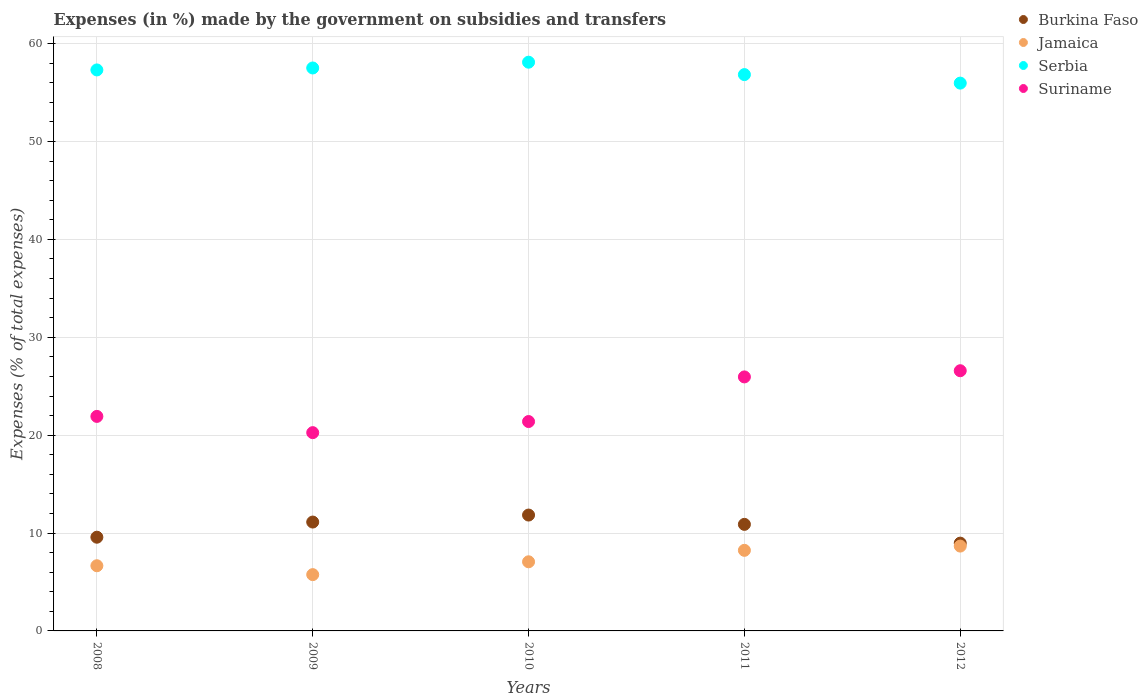How many different coloured dotlines are there?
Ensure brevity in your answer.  4. What is the percentage of expenses made by the government on subsidies and transfers in Suriname in 2009?
Your answer should be compact. 20.26. Across all years, what is the maximum percentage of expenses made by the government on subsidies and transfers in Burkina Faso?
Make the answer very short. 11.84. Across all years, what is the minimum percentage of expenses made by the government on subsidies and transfers in Burkina Faso?
Offer a very short reply. 8.97. What is the total percentage of expenses made by the government on subsidies and transfers in Jamaica in the graph?
Your answer should be compact. 36.37. What is the difference between the percentage of expenses made by the government on subsidies and transfers in Suriname in 2008 and that in 2009?
Your answer should be compact. 1.66. What is the difference between the percentage of expenses made by the government on subsidies and transfers in Burkina Faso in 2011 and the percentage of expenses made by the government on subsidies and transfers in Jamaica in 2012?
Offer a very short reply. 2.22. What is the average percentage of expenses made by the government on subsidies and transfers in Jamaica per year?
Offer a very short reply. 7.27. In the year 2009, what is the difference between the percentage of expenses made by the government on subsidies and transfers in Serbia and percentage of expenses made by the government on subsidies and transfers in Jamaica?
Your answer should be very brief. 51.76. What is the ratio of the percentage of expenses made by the government on subsidies and transfers in Serbia in 2008 to that in 2012?
Your answer should be very brief. 1.02. Is the percentage of expenses made by the government on subsidies and transfers in Suriname in 2008 less than that in 2011?
Make the answer very short. Yes. What is the difference between the highest and the second highest percentage of expenses made by the government on subsidies and transfers in Jamaica?
Your answer should be very brief. 0.43. What is the difference between the highest and the lowest percentage of expenses made by the government on subsidies and transfers in Burkina Faso?
Give a very brief answer. 2.87. Is the sum of the percentage of expenses made by the government on subsidies and transfers in Suriname in 2008 and 2012 greater than the maximum percentage of expenses made by the government on subsidies and transfers in Serbia across all years?
Your answer should be compact. No. Is it the case that in every year, the sum of the percentage of expenses made by the government on subsidies and transfers in Suriname and percentage of expenses made by the government on subsidies and transfers in Jamaica  is greater than the sum of percentage of expenses made by the government on subsidies and transfers in Serbia and percentage of expenses made by the government on subsidies and transfers in Burkina Faso?
Your answer should be compact. Yes. Is the percentage of expenses made by the government on subsidies and transfers in Serbia strictly greater than the percentage of expenses made by the government on subsidies and transfers in Burkina Faso over the years?
Ensure brevity in your answer.  Yes. Is the percentage of expenses made by the government on subsidies and transfers in Jamaica strictly less than the percentage of expenses made by the government on subsidies and transfers in Serbia over the years?
Keep it short and to the point. Yes. How many years are there in the graph?
Provide a succinct answer. 5. Where does the legend appear in the graph?
Offer a very short reply. Top right. How many legend labels are there?
Offer a terse response. 4. What is the title of the graph?
Your answer should be very brief. Expenses (in %) made by the government on subsidies and transfers. What is the label or title of the X-axis?
Give a very brief answer. Years. What is the label or title of the Y-axis?
Make the answer very short. Expenses (% of total expenses). What is the Expenses (% of total expenses) in Burkina Faso in 2008?
Make the answer very short. 9.57. What is the Expenses (% of total expenses) in Jamaica in 2008?
Ensure brevity in your answer.  6.66. What is the Expenses (% of total expenses) in Serbia in 2008?
Your answer should be compact. 57.32. What is the Expenses (% of total expenses) in Suriname in 2008?
Provide a succinct answer. 21.92. What is the Expenses (% of total expenses) of Burkina Faso in 2009?
Provide a succinct answer. 11.12. What is the Expenses (% of total expenses) of Jamaica in 2009?
Offer a very short reply. 5.75. What is the Expenses (% of total expenses) of Serbia in 2009?
Your response must be concise. 57.52. What is the Expenses (% of total expenses) of Suriname in 2009?
Provide a succinct answer. 20.26. What is the Expenses (% of total expenses) in Burkina Faso in 2010?
Give a very brief answer. 11.84. What is the Expenses (% of total expenses) in Jamaica in 2010?
Make the answer very short. 7.06. What is the Expenses (% of total expenses) in Serbia in 2010?
Provide a succinct answer. 58.11. What is the Expenses (% of total expenses) in Suriname in 2010?
Ensure brevity in your answer.  21.39. What is the Expenses (% of total expenses) in Burkina Faso in 2011?
Your answer should be compact. 10.89. What is the Expenses (% of total expenses) of Jamaica in 2011?
Ensure brevity in your answer.  8.23. What is the Expenses (% of total expenses) in Serbia in 2011?
Provide a succinct answer. 56.84. What is the Expenses (% of total expenses) in Suriname in 2011?
Offer a terse response. 25.95. What is the Expenses (% of total expenses) in Burkina Faso in 2012?
Give a very brief answer. 8.97. What is the Expenses (% of total expenses) in Jamaica in 2012?
Provide a short and direct response. 8.67. What is the Expenses (% of total expenses) of Serbia in 2012?
Ensure brevity in your answer.  55.97. What is the Expenses (% of total expenses) in Suriname in 2012?
Your answer should be very brief. 26.58. Across all years, what is the maximum Expenses (% of total expenses) of Burkina Faso?
Keep it short and to the point. 11.84. Across all years, what is the maximum Expenses (% of total expenses) in Jamaica?
Keep it short and to the point. 8.67. Across all years, what is the maximum Expenses (% of total expenses) of Serbia?
Make the answer very short. 58.11. Across all years, what is the maximum Expenses (% of total expenses) in Suriname?
Provide a succinct answer. 26.58. Across all years, what is the minimum Expenses (% of total expenses) in Burkina Faso?
Your answer should be very brief. 8.97. Across all years, what is the minimum Expenses (% of total expenses) of Jamaica?
Keep it short and to the point. 5.75. Across all years, what is the minimum Expenses (% of total expenses) of Serbia?
Give a very brief answer. 55.97. Across all years, what is the minimum Expenses (% of total expenses) of Suriname?
Ensure brevity in your answer.  20.26. What is the total Expenses (% of total expenses) of Burkina Faso in the graph?
Your answer should be very brief. 52.39. What is the total Expenses (% of total expenses) of Jamaica in the graph?
Provide a succinct answer. 36.37. What is the total Expenses (% of total expenses) in Serbia in the graph?
Ensure brevity in your answer.  285.75. What is the total Expenses (% of total expenses) in Suriname in the graph?
Your answer should be compact. 116.1. What is the difference between the Expenses (% of total expenses) in Burkina Faso in 2008 and that in 2009?
Provide a succinct answer. -1.55. What is the difference between the Expenses (% of total expenses) in Jamaica in 2008 and that in 2009?
Your answer should be very brief. 0.91. What is the difference between the Expenses (% of total expenses) of Serbia in 2008 and that in 2009?
Provide a short and direct response. -0.2. What is the difference between the Expenses (% of total expenses) of Suriname in 2008 and that in 2009?
Your response must be concise. 1.66. What is the difference between the Expenses (% of total expenses) of Burkina Faso in 2008 and that in 2010?
Offer a terse response. -2.26. What is the difference between the Expenses (% of total expenses) in Jamaica in 2008 and that in 2010?
Offer a terse response. -0.4. What is the difference between the Expenses (% of total expenses) of Serbia in 2008 and that in 2010?
Your response must be concise. -0.79. What is the difference between the Expenses (% of total expenses) in Suriname in 2008 and that in 2010?
Your answer should be very brief. 0.53. What is the difference between the Expenses (% of total expenses) of Burkina Faso in 2008 and that in 2011?
Your response must be concise. -1.31. What is the difference between the Expenses (% of total expenses) of Jamaica in 2008 and that in 2011?
Your answer should be compact. -1.57. What is the difference between the Expenses (% of total expenses) of Serbia in 2008 and that in 2011?
Keep it short and to the point. 0.48. What is the difference between the Expenses (% of total expenses) in Suriname in 2008 and that in 2011?
Your response must be concise. -4.03. What is the difference between the Expenses (% of total expenses) of Burkina Faso in 2008 and that in 2012?
Offer a terse response. 0.61. What is the difference between the Expenses (% of total expenses) of Jamaica in 2008 and that in 2012?
Make the answer very short. -2.01. What is the difference between the Expenses (% of total expenses) of Serbia in 2008 and that in 2012?
Offer a very short reply. 1.35. What is the difference between the Expenses (% of total expenses) of Suriname in 2008 and that in 2012?
Offer a terse response. -4.67. What is the difference between the Expenses (% of total expenses) of Burkina Faso in 2009 and that in 2010?
Provide a succinct answer. -0.71. What is the difference between the Expenses (% of total expenses) in Jamaica in 2009 and that in 2010?
Ensure brevity in your answer.  -1.31. What is the difference between the Expenses (% of total expenses) in Serbia in 2009 and that in 2010?
Provide a succinct answer. -0.59. What is the difference between the Expenses (% of total expenses) of Suriname in 2009 and that in 2010?
Provide a short and direct response. -1.13. What is the difference between the Expenses (% of total expenses) of Burkina Faso in 2009 and that in 2011?
Offer a terse response. 0.24. What is the difference between the Expenses (% of total expenses) in Jamaica in 2009 and that in 2011?
Keep it short and to the point. -2.48. What is the difference between the Expenses (% of total expenses) in Serbia in 2009 and that in 2011?
Your response must be concise. 0.68. What is the difference between the Expenses (% of total expenses) of Suriname in 2009 and that in 2011?
Your answer should be compact. -5.69. What is the difference between the Expenses (% of total expenses) of Burkina Faso in 2009 and that in 2012?
Your answer should be very brief. 2.15. What is the difference between the Expenses (% of total expenses) in Jamaica in 2009 and that in 2012?
Provide a succinct answer. -2.92. What is the difference between the Expenses (% of total expenses) of Serbia in 2009 and that in 2012?
Offer a terse response. 1.55. What is the difference between the Expenses (% of total expenses) in Suriname in 2009 and that in 2012?
Provide a succinct answer. -6.33. What is the difference between the Expenses (% of total expenses) of Burkina Faso in 2010 and that in 2011?
Your response must be concise. 0.95. What is the difference between the Expenses (% of total expenses) in Jamaica in 2010 and that in 2011?
Provide a succinct answer. -1.17. What is the difference between the Expenses (% of total expenses) of Serbia in 2010 and that in 2011?
Offer a terse response. 1.27. What is the difference between the Expenses (% of total expenses) of Suriname in 2010 and that in 2011?
Give a very brief answer. -4.56. What is the difference between the Expenses (% of total expenses) in Burkina Faso in 2010 and that in 2012?
Give a very brief answer. 2.87. What is the difference between the Expenses (% of total expenses) in Jamaica in 2010 and that in 2012?
Ensure brevity in your answer.  -1.6. What is the difference between the Expenses (% of total expenses) in Serbia in 2010 and that in 2012?
Offer a terse response. 2.14. What is the difference between the Expenses (% of total expenses) of Suriname in 2010 and that in 2012?
Offer a very short reply. -5.19. What is the difference between the Expenses (% of total expenses) of Burkina Faso in 2011 and that in 2012?
Make the answer very short. 1.92. What is the difference between the Expenses (% of total expenses) of Jamaica in 2011 and that in 2012?
Keep it short and to the point. -0.43. What is the difference between the Expenses (% of total expenses) of Serbia in 2011 and that in 2012?
Your response must be concise. 0.87. What is the difference between the Expenses (% of total expenses) of Suriname in 2011 and that in 2012?
Ensure brevity in your answer.  -0.63. What is the difference between the Expenses (% of total expenses) in Burkina Faso in 2008 and the Expenses (% of total expenses) in Jamaica in 2009?
Provide a succinct answer. 3.82. What is the difference between the Expenses (% of total expenses) in Burkina Faso in 2008 and the Expenses (% of total expenses) in Serbia in 2009?
Your response must be concise. -47.94. What is the difference between the Expenses (% of total expenses) in Burkina Faso in 2008 and the Expenses (% of total expenses) in Suriname in 2009?
Give a very brief answer. -10.68. What is the difference between the Expenses (% of total expenses) of Jamaica in 2008 and the Expenses (% of total expenses) of Serbia in 2009?
Provide a short and direct response. -50.86. What is the difference between the Expenses (% of total expenses) of Jamaica in 2008 and the Expenses (% of total expenses) of Suriname in 2009?
Keep it short and to the point. -13.6. What is the difference between the Expenses (% of total expenses) of Serbia in 2008 and the Expenses (% of total expenses) of Suriname in 2009?
Your answer should be compact. 37.06. What is the difference between the Expenses (% of total expenses) in Burkina Faso in 2008 and the Expenses (% of total expenses) in Jamaica in 2010?
Ensure brevity in your answer.  2.51. What is the difference between the Expenses (% of total expenses) in Burkina Faso in 2008 and the Expenses (% of total expenses) in Serbia in 2010?
Your answer should be very brief. -48.53. What is the difference between the Expenses (% of total expenses) of Burkina Faso in 2008 and the Expenses (% of total expenses) of Suriname in 2010?
Provide a succinct answer. -11.82. What is the difference between the Expenses (% of total expenses) in Jamaica in 2008 and the Expenses (% of total expenses) in Serbia in 2010?
Your response must be concise. -51.45. What is the difference between the Expenses (% of total expenses) in Jamaica in 2008 and the Expenses (% of total expenses) in Suriname in 2010?
Give a very brief answer. -14.73. What is the difference between the Expenses (% of total expenses) of Serbia in 2008 and the Expenses (% of total expenses) of Suriname in 2010?
Your answer should be compact. 35.92. What is the difference between the Expenses (% of total expenses) in Burkina Faso in 2008 and the Expenses (% of total expenses) in Jamaica in 2011?
Your answer should be compact. 1.34. What is the difference between the Expenses (% of total expenses) of Burkina Faso in 2008 and the Expenses (% of total expenses) of Serbia in 2011?
Your response must be concise. -47.26. What is the difference between the Expenses (% of total expenses) in Burkina Faso in 2008 and the Expenses (% of total expenses) in Suriname in 2011?
Your response must be concise. -16.38. What is the difference between the Expenses (% of total expenses) in Jamaica in 2008 and the Expenses (% of total expenses) in Serbia in 2011?
Your response must be concise. -50.18. What is the difference between the Expenses (% of total expenses) of Jamaica in 2008 and the Expenses (% of total expenses) of Suriname in 2011?
Keep it short and to the point. -19.29. What is the difference between the Expenses (% of total expenses) of Serbia in 2008 and the Expenses (% of total expenses) of Suriname in 2011?
Provide a short and direct response. 31.36. What is the difference between the Expenses (% of total expenses) of Burkina Faso in 2008 and the Expenses (% of total expenses) of Jamaica in 2012?
Offer a very short reply. 0.91. What is the difference between the Expenses (% of total expenses) of Burkina Faso in 2008 and the Expenses (% of total expenses) of Serbia in 2012?
Provide a succinct answer. -46.39. What is the difference between the Expenses (% of total expenses) in Burkina Faso in 2008 and the Expenses (% of total expenses) in Suriname in 2012?
Give a very brief answer. -17.01. What is the difference between the Expenses (% of total expenses) of Jamaica in 2008 and the Expenses (% of total expenses) of Serbia in 2012?
Offer a very short reply. -49.31. What is the difference between the Expenses (% of total expenses) in Jamaica in 2008 and the Expenses (% of total expenses) in Suriname in 2012?
Offer a very short reply. -19.92. What is the difference between the Expenses (% of total expenses) in Serbia in 2008 and the Expenses (% of total expenses) in Suriname in 2012?
Your answer should be compact. 30.73. What is the difference between the Expenses (% of total expenses) in Burkina Faso in 2009 and the Expenses (% of total expenses) in Jamaica in 2010?
Provide a short and direct response. 4.06. What is the difference between the Expenses (% of total expenses) of Burkina Faso in 2009 and the Expenses (% of total expenses) of Serbia in 2010?
Make the answer very short. -46.98. What is the difference between the Expenses (% of total expenses) in Burkina Faso in 2009 and the Expenses (% of total expenses) in Suriname in 2010?
Give a very brief answer. -10.27. What is the difference between the Expenses (% of total expenses) in Jamaica in 2009 and the Expenses (% of total expenses) in Serbia in 2010?
Offer a terse response. -52.36. What is the difference between the Expenses (% of total expenses) of Jamaica in 2009 and the Expenses (% of total expenses) of Suriname in 2010?
Offer a terse response. -15.64. What is the difference between the Expenses (% of total expenses) in Serbia in 2009 and the Expenses (% of total expenses) in Suriname in 2010?
Make the answer very short. 36.12. What is the difference between the Expenses (% of total expenses) in Burkina Faso in 2009 and the Expenses (% of total expenses) in Jamaica in 2011?
Your response must be concise. 2.89. What is the difference between the Expenses (% of total expenses) of Burkina Faso in 2009 and the Expenses (% of total expenses) of Serbia in 2011?
Give a very brief answer. -45.72. What is the difference between the Expenses (% of total expenses) of Burkina Faso in 2009 and the Expenses (% of total expenses) of Suriname in 2011?
Make the answer very short. -14.83. What is the difference between the Expenses (% of total expenses) in Jamaica in 2009 and the Expenses (% of total expenses) in Serbia in 2011?
Your answer should be very brief. -51.09. What is the difference between the Expenses (% of total expenses) in Jamaica in 2009 and the Expenses (% of total expenses) in Suriname in 2011?
Your response must be concise. -20.2. What is the difference between the Expenses (% of total expenses) of Serbia in 2009 and the Expenses (% of total expenses) of Suriname in 2011?
Your answer should be very brief. 31.56. What is the difference between the Expenses (% of total expenses) of Burkina Faso in 2009 and the Expenses (% of total expenses) of Jamaica in 2012?
Ensure brevity in your answer.  2.46. What is the difference between the Expenses (% of total expenses) in Burkina Faso in 2009 and the Expenses (% of total expenses) in Serbia in 2012?
Provide a short and direct response. -44.85. What is the difference between the Expenses (% of total expenses) in Burkina Faso in 2009 and the Expenses (% of total expenses) in Suriname in 2012?
Make the answer very short. -15.46. What is the difference between the Expenses (% of total expenses) of Jamaica in 2009 and the Expenses (% of total expenses) of Serbia in 2012?
Keep it short and to the point. -50.22. What is the difference between the Expenses (% of total expenses) of Jamaica in 2009 and the Expenses (% of total expenses) of Suriname in 2012?
Provide a short and direct response. -20.83. What is the difference between the Expenses (% of total expenses) in Serbia in 2009 and the Expenses (% of total expenses) in Suriname in 2012?
Your response must be concise. 30.93. What is the difference between the Expenses (% of total expenses) of Burkina Faso in 2010 and the Expenses (% of total expenses) of Jamaica in 2011?
Ensure brevity in your answer.  3.6. What is the difference between the Expenses (% of total expenses) in Burkina Faso in 2010 and the Expenses (% of total expenses) in Serbia in 2011?
Keep it short and to the point. -45. What is the difference between the Expenses (% of total expenses) in Burkina Faso in 2010 and the Expenses (% of total expenses) in Suriname in 2011?
Your response must be concise. -14.11. What is the difference between the Expenses (% of total expenses) of Jamaica in 2010 and the Expenses (% of total expenses) of Serbia in 2011?
Give a very brief answer. -49.78. What is the difference between the Expenses (% of total expenses) in Jamaica in 2010 and the Expenses (% of total expenses) in Suriname in 2011?
Provide a succinct answer. -18.89. What is the difference between the Expenses (% of total expenses) in Serbia in 2010 and the Expenses (% of total expenses) in Suriname in 2011?
Your response must be concise. 32.15. What is the difference between the Expenses (% of total expenses) of Burkina Faso in 2010 and the Expenses (% of total expenses) of Jamaica in 2012?
Provide a succinct answer. 3.17. What is the difference between the Expenses (% of total expenses) in Burkina Faso in 2010 and the Expenses (% of total expenses) in Serbia in 2012?
Make the answer very short. -44.13. What is the difference between the Expenses (% of total expenses) in Burkina Faso in 2010 and the Expenses (% of total expenses) in Suriname in 2012?
Give a very brief answer. -14.75. What is the difference between the Expenses (% of total expenses) in Jamaica in 2010 and the Expenses (% of total expenses) in Serbia in 2012?
Offer a terse response. -48.91. What is the difference between the Expenses (% of total expenses) of Jamaica in 2010 and the Expenses (% of total expenses) of Suriname in 2012?
Offer a terse response. -19.52. What is the difference between the Expenses (% of total expenses) of Serbia in 2010 and the Expenses (% of total expenses) of Suriname in 2012?
Ensure brevity in your answer.  31.52. What is the difference between the Expenses (% of total expenses) of Burkina Faso in 2011 and the Expenses (% of total expenses) of Jamaica in 2012?
Keep it short and to the point. 2.22. What is the difference between the Expenses (% of total expenses) of Burkina Faso in 2011 and the Expenses (% of total expenses) of Serbia in 2012?
Ensure brevity in your answer.  -45.08. What is the difference between the Expenses (% of total expenses) in Burkina Faso in 2011 and the Expenses (% of total expenses) in Suriname in 2012?
Your answer should be very brief. -15.7. What is the difference between the Expenses (% of total expenses) in Jamaica in 2011 and the Expenses (% of total expenses) in Serbia in 2012?
Your response must be concise. -47.74. What is the difference between the Expenses (% of total expenses) of Jamaica in 2011 and the Expenses (% of total expenses) of Suriname in 2012?
Keep it short and to the point. -18.35. What is the difference between the Expenses (% of total expenses) of Serbia in 2011 and the Expenses (% of total expenses) of Suriname in 2012?
Your answer should be compact. 30.26. What is the average Expenses (% of total expenses) of Burkina Faso per year?
Give a very brief answer. 10.48. What is the average Expenses (% of total expenses) of Jamaica per year?
Provide a succinct answer. 7.27. What is the average Expenses (% of total expenses) of Serbia per year?
Your answer should be very brief. 57.15. What is the average Expenses (% of total expenses) of Suriname per year?
Provide a succinct answer. 23.22. In the year 2008, what is the difference between the Expenses (% of total expenses) in Burkina Faso and Expenses (% of total expenses) in Jamaica?
Your answer should be compact. 2.91. In the year 2008, what is the difference between the Expenses (% of total expenses) of Burkina Faso and Expenses (% of total expenses) of Serbia?
Your response must be concise. -47.74. In the year 2008, what is the difference between the Expenses (% of total expenses) in Burkina Faso and Expenses (% of total expenses) in Suriname?
Make the answer very short. -12.34. In the year 2008, what is the difference between the Expenses (% of total expenses) of Jamaica and Expenses (% of total expenses) of Serbia?
Ensure brevity in your answer.  -50.66. In the year 2008, what is the difference between the Expenses (% of total expenses) of Jamaica and Expenses (% of total expenses) of Suriname?
Offer a terse response. -15.26. In the year 2008, what is the difference between the Expenses (% of total expenses) of Serbia and Expenses (% of total expenses) of Suriname?
Your response must be concise. 35.4. In the year 2009, what is the difference between the Expenses (% of total expenses) in Burkina Faso and Expenses (% of total expenses) in Jamaica?
Ensure brevity in your answer.  5.37. In the year 2009, what is the difference between the Expenses (% of total expenses) of Burkina Faso and Expenses (% of total expenses) of Serbia?
Give a very brief answer. -46.39. In the year 2009, what is the difference between the Expenses (% of total expenses) of Burkina Faso and Expenses (% of total expenses) of Suriname?
Ensure brevity in your answer.  -9.13. In the year 2009, what is the difference between the Expenses (% of total expenses) in Jamaica and Expenses (% of total expenses) in Serbia?
Offer a terse response. -51.76. In the year 2009, what is the difference between the Expenses (% of total expenses) in Jamaica and Expenses (% of total expenses) in Suriname?
Provide a succinct answer. -14.51. In the year 2009, what is the difference between the Expenses (% of total expenses) of Serbia and Expenses (% of total expenses) of Suriname?
Make the answer very short. 37.26. In the year 2010, what is the difference between the Expenses (% of total expenses) in Burkina Faso and Expenses (% of total expenses) in Jamaica?
Make the answer very short. 4.78. In the year 2010, what is the difference between the Expenses (% of total expenses) of Burkina Faso and Expenses (% of total expenses) of Serbia?
Give a very brief answer. -46.27. In the year 2010, what is the difference between the Expenses (% of total expenses) in Burkina Faso and Expenses (% of total expenses) in Suriname?
Your answer should be very brief. -9.55. In the year 2010, what is the difference between the Expenses (% of total expenses) of Jamaica and Expenses (% of total expenses) of Serbia?
Make the answer very short. -51.04. In the year 2010, what is the difference between the Expenses (% of total expenses) in Jamaica and Expenses (% of total expenses) in Suriname?
Provide a short and direct response. -14.33. In the year 2010, what is the difference between the Expenses (% of total expenses) of Serbia and Expenses (% of total expenses) of Suriname?
Provide a short and direct response. 36.71. In the year 2011, what is the difference between the Expenses (% of total expenses) of Burkina Faso and Expenses (% of total expenses) of Jamaica?
Give a very brief answer. 2.65. In the year 2011, what is the difference between the Expenses (% of total expenses) of Burkina Faso and Expenses (% of total expenses) of Serbia?
Provide a succinct answer. -45.95. In the year 2011, what is the difference between the Expenses (% of total expenses) of Burkina Faso and Expenses (% of total expenses) of Suriname?
Offer a terse response. -15.07. In the year 2011, what is the difference between the Expenses (% of total expenses) of Jamaica and Expenses (% of total expenses) of Serbia?
Your answer should be very brief. -48.61. In the year 2011, what is the difference between the Expenses (% of total expenses) in Jamaica and Expenses (% of total expenses) in Suriname?
Keep it short and to the point. -17.72. In the year 2011, what is the difference between the Expenses (% of total expenses) of Serbia and Expenses (% of total expenses) of Suriname?
Offer a very short reply. 30.89. In the year 2012, what is the difference between the Expenses (% of total expenses) of Burkina Faso and Expenses (% of total expenses) of Jamaica?
Your response must be concise. 0.3. In the year 2012, what is the difference between the Expenses (% of total expenses) in Burkina Faso and Expenses (% of total expenses) in Serbia?
Your answer should be very brief. -47. In the year 2012, what is the difference between the Expenses (% of total expenses) of Burkina Faso and Expenses (% of total expenses) of Suriname?
Provide a succinct answer. -17.61. In the year 2012, what is the difference between the Expenses (% of total expenses) of Jamaica and Expenses (% of total expenses) of Serbia?
Give a very brief answer. -47.3. In the year 2012, what is the difference between the Expenses (% of total expenses) in Jamaica and Expenses (% of total expenses) in Suriname?
Your answer should be very brief. -17.92. In the year 2012, what is the difference between the Expenses (% of total expenses) in Serbia and Expenses (% of total expenses) in Suriname?
Your answer should be compact. 29.38. What is the ratio of the Expenses (% of total expenses) of Burkina Faso in 2008 to that in 2009?
Provide a succinct answer. 0.86. What is the ratio of the Expenses (% of total expenses) in Jamaica in 2008 to that in 2009?
Your answer should be very brief. 1.16. What is the ratio of the Expenses (% of total expenses) in Suriname in 2008 to that in 2009?
Your answer should be very brief. 1.08. What is the ratio of the Expenses (% of total expenses) in Burkina Faso in 2008 to that in 2010?
Give a very brief answer. 0.81. What is the ratio of the Expenses (% of total expenses) of Jamaica in 2008 to that in 2010?
Provide a short and direct response. 0.94. What is the ratio of the Expenses (% of total expenses) in Serbia in 2008 to that in 2010?
Your response must be concise. 0.99. What is the ratio of the Expenses (% of total expenses) of Suriname in 2008 to that in 2010?
Give a very brief answer. 1.02. What is the ratio of the Expenses (% of total expenses) in Burkina Faso in 2008 to that in 2011?
Give a very brief answer. 0.88. What is the ratio of the Expenses (% of total expenses) in Jamaica in 2008 to that in 2011?
Provide a succinct answer. 0.81. What is the ratio of the Expenses (% of total expenses) in Serbia in 2008 to that in 2011?
Ensure brevity in your answer.  1.01. What is the ratio of the Expenses (% of total expenses) in Suriname in 2008 to that in 2011?
Your response must be concise. 0.84. What is the ratio of the Expenses (% of total expenses) of Burkina Faso in 2008 to that in 2012?
Your response must be concise. 1.07. What is the ratio of the Expenses (% of total expenses) in Jamaica in 2008 to that in 2012?
Ensure brevity in your answer.  0.77. What is the ratio of the Expenses (% of total expenses) of Serbia in 2008 to that in 2012?
Offer a very short reply. 1.02. What is the ratio of the Expenses (% of total expenses) of Suriname in 2008 to that in 2012?
Your answer should be very brief. 0.82. What is the ratio of the Expenses (% of total expenses) in Burkina Faso in 2009 to that in 2010?
Offer a very short reply. 0.94. What is the ratio of the Expenses (% of total expenses) in Jamaica in 2009 to that in 2010?
Your answer should be very brief. 0.81. What is the ratio of the Expenses (% of total expenses) in Suriname in 2009 to that in 2010?
Provide a short and direct response. 0.95. What is the ratio of the Expenses (% of total expenses) in Burkina Faso in 2009 to that in 2011?
Your answer should be compact. 1.02. What is the ratio of the Expenses (% of total expenses) in Jamaica in 2009 to that in 2011?
Your answer should be compact. 0.7. What is the ratio of the Expenses (% of total expenses) of Serbia in 2009 to that in 2011?
Ensure brevity in your answer.  1.01. What is the ratio of the Expenses (% of total expenses) in Suriname in 2009 to that in 2011?
Keep it short and to the point. 0.78. What is the ratio of the Expenses (% of total expenses) of Burkina Faso in 2009 to that in 2012?
Your answer should be very brief. 1.24. What is the ratio of the Expenses (% of total expenses) of Jamaica in 2009 to that in 2012?
Provide a succinct answer. 0.66. What is the ratio of the Expenses (% of total expenses) in Serbia in 2009 to that in 2012?
Provide a succinct answer. 1.03. What is the ratio of the Expenses (% of total expenses) of Suriname in 2009 to that in 2012?
Your answer should be very brief. 0.76. What is the ratio of the Expenses (% of total expenses) of Burkina Faso in 2010 to that in 2011?
Give a very brief answer. 1.09. What is the ratio of the Expenses (% of total expenses) in Jamaica in 2010 to that in 2011?
Give a very brief answer. 0.86. What is the ratio of the Expenses (% of total expenses) in Serbia in 2010 to that in 2011?
Give a very brief answer. 1.02. What is the ratio of the Expenses (% of total expenses) of Suriname in 2010 to that in 2011?
Make the answer very short. 0.82. What is the ratio of the Expenses (% of total expenses) in Burkina Faso in 2010 to that in 2012?
Ensure brevity in your answer.  1.32. What is the ratio of the Expenses (% of total expenses) in Jamaica in 2010 to that in 2012?
Provide a succinct answer. 0.81. What is the ratio of the Expenses (% of total expenses) in Serbia in 2010 to that in 2012?
Ensure brevity in your answer.  1.04. What is the ratio of the Expenses (% of total expenses) in Suriname in 2010 to that in 2012?
Provide a succinct answer. 0.8. What is the ratio of the Expenses (% of total expenses) in Burkina Faso in 2011 to that in 2012?
Your answer should be very brief. 1.21. What is the ratio of the Expenses (% of total expenses) in Jamaica in 2011 to that in 2012?
Provide a short and direct response. 0.95. What is the ratio of the Expenses (% of total expenses) in Serbia in 2011 to that in 2012?
Your response must be concise. 1.02. What is the ratio of the Expenses (% of total expenses) of Suriname in 2011 to that in 2012?
Give a very brief answer. 0.98. What is the difference between the highest and the second highest Expenses (% of total expenses) in Burkina Faso?
Your answer should be very brief. 0.71. What is the difference between the highest and the second highest Expenses (% of total expenses) in Jamaica?
Keep it short and to the point. 0.43. What is the difference between the highest and the second highest Expenses (% of total expenses) of Serbia?
Offer a very short reply. 0.59. What is the difference between the highest and the second highest Expenses (% of total expenses) in Suriname?
Provide a short and direct response. 0.63. What is the difference between the highest and the lowest Expenses (% of total expenses) of Burkina Faso?
Keep it short and to the point. 2.87. What is the difference between the highest and the lowest Expenses (% of total expenses) of Jamaica?
Keep it short and to the point. 2.92. What is the difference between the highest and the lowest Expenses (% of total expenses) in Serbia?
Make the answer very short. 2.14. What is the difference between the highest and the lowest Expenses (% of total expenses) in Suriname?
Ensure brevity in your answer.  6.33. 